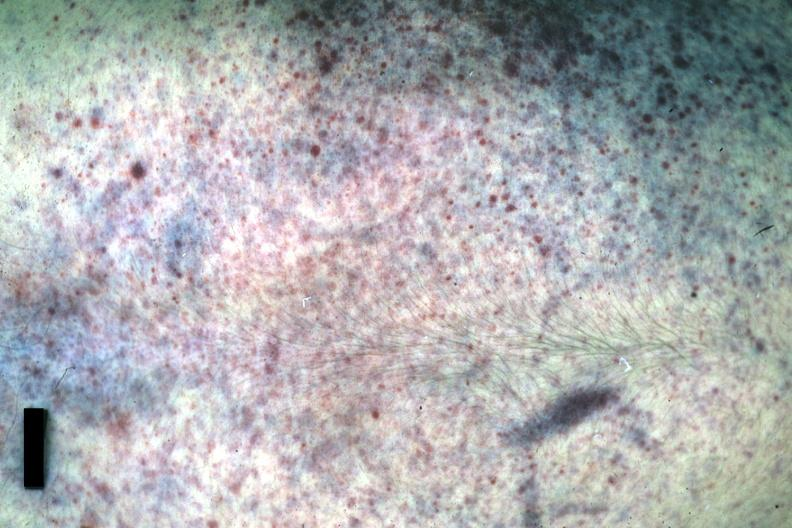s petechiae present?
Answer the question using a single word or phrase. Yes 